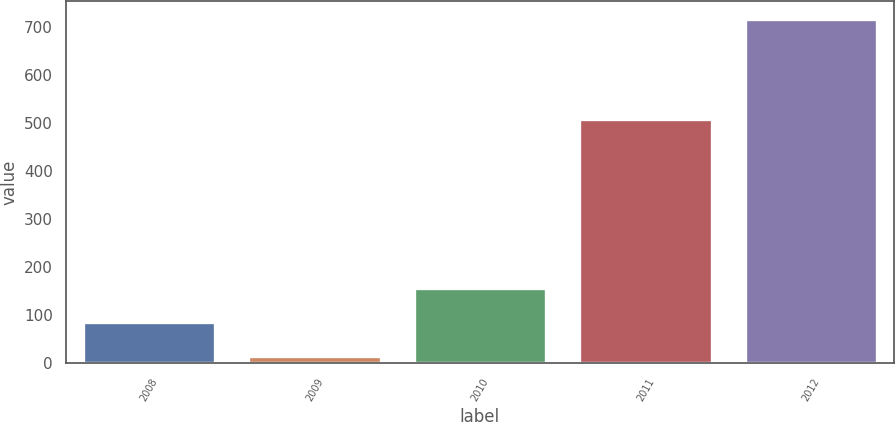<chart> <loc_0><loc_0><loc_500><loc_500><bar_chart><fcel>2008<fcel>2009<fcel>2010<fcel>2011<fcel>2012<nl><fcel>85.86<fcel>15.6<fcel>156.12<fcel>508.7<fcel>718.2<nl></chart> 